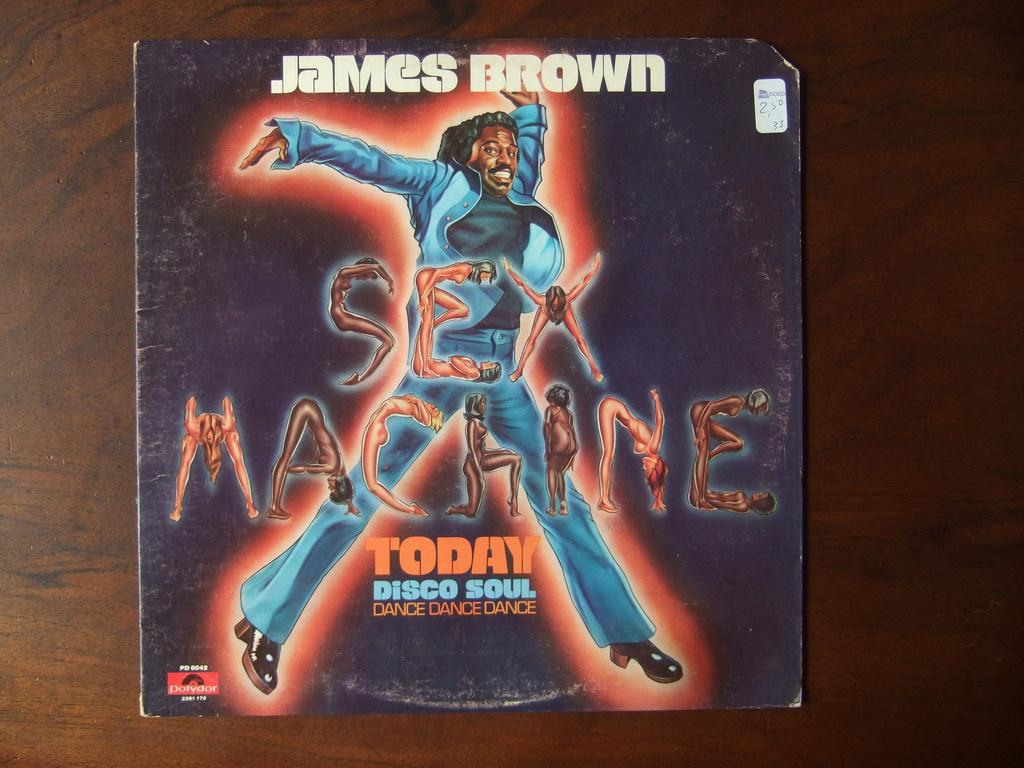<image>
Provide a brief description of the given image. A worn record Sex Machine by James Brown. 